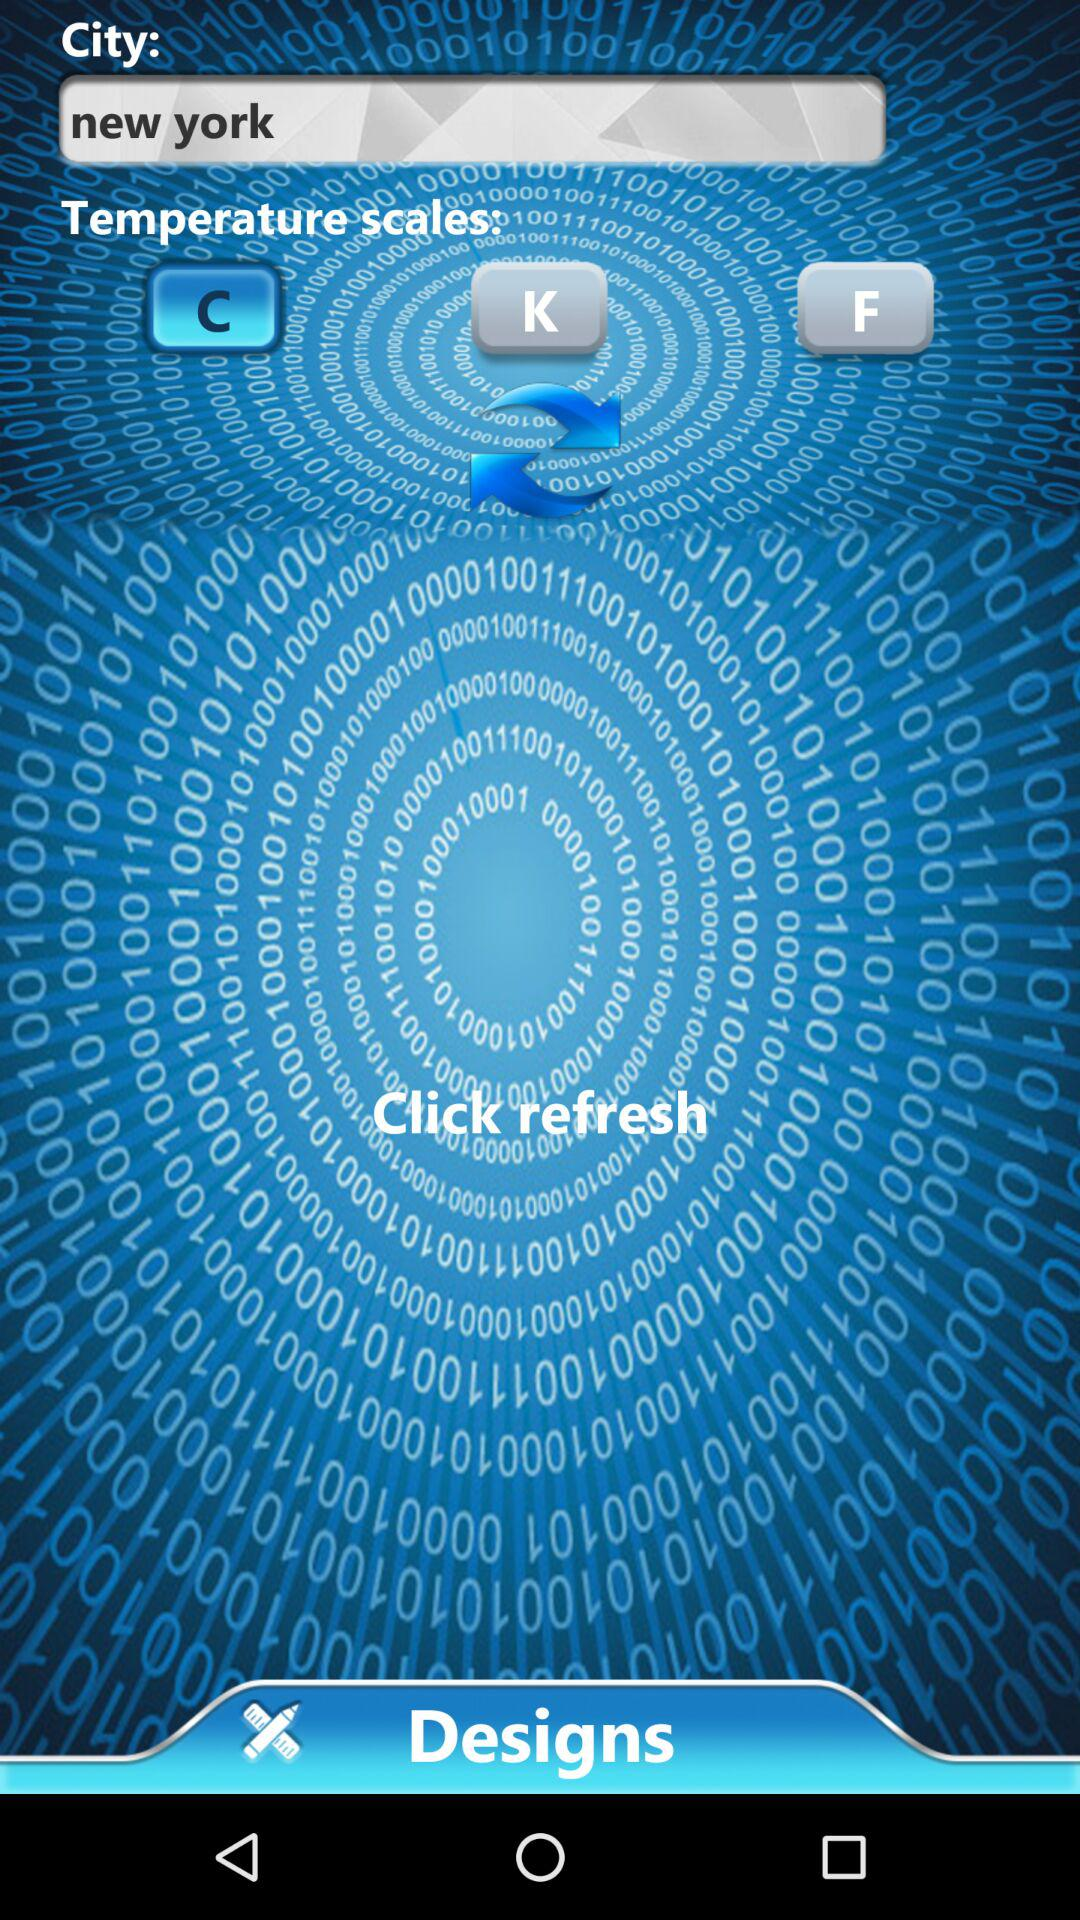Which city is selected? The selected city is New York. 